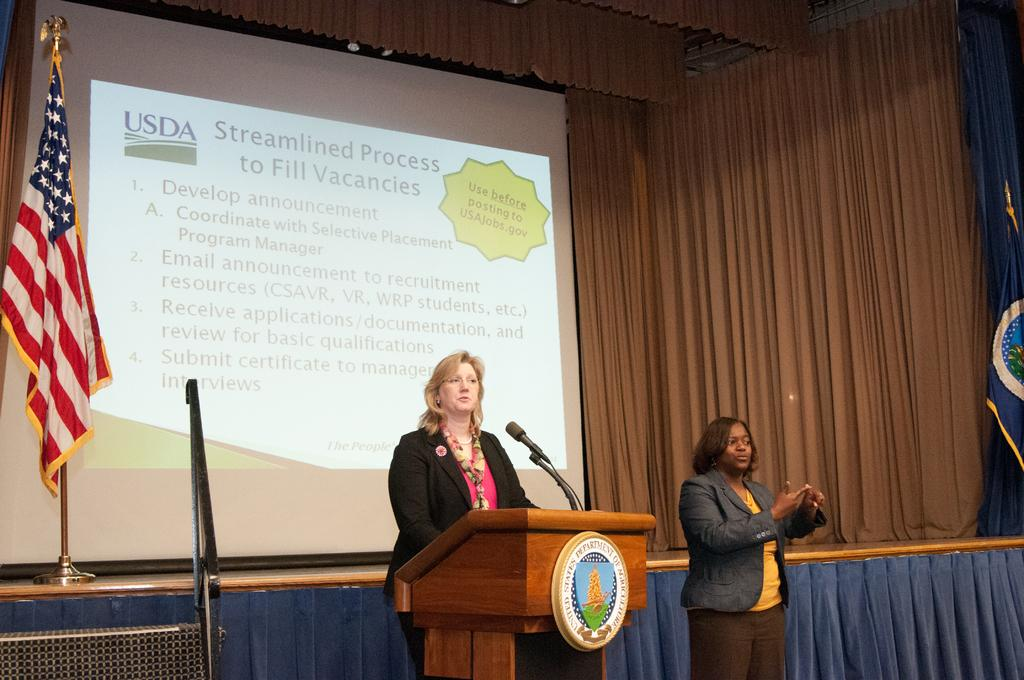How many women are on the stage in the image? There are two women standing on the stage in the image. What objects are on the stage with the women? There is a table and a microphone on the stage. What can be seen in the background of the image? There is a curtain, a flag, and a screen in the background. Where was the image taken? The image was taken in a hall. What angle does the head of the first woman make with the microphone in the image? There is no information about the angle of the women's heads in relation to the microphone in the image. 